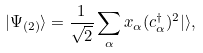<formula> <loc_0><loc_0><loc_500><loc_500>| \Psi _ { ( 2 ) } \rangle = \frac { 1 } { \sqrt { 2 } } \sum _ { \alpha } x _ { \alpha } ( c ^ { \dagger } _ { \alpha } ) ^ { 2 } | \rangle ,</formula> 